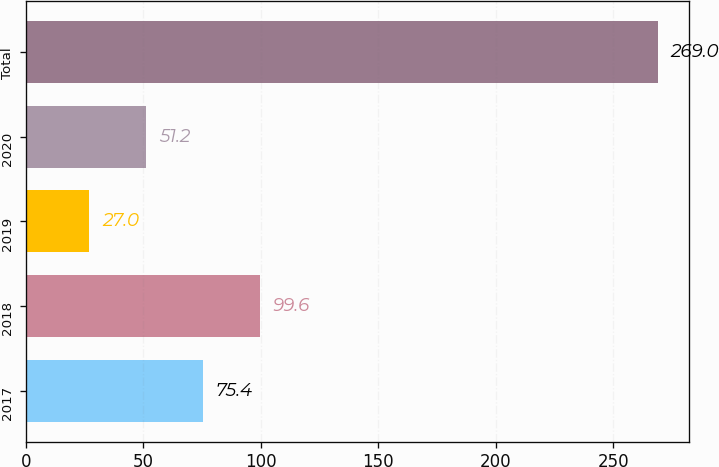Convert chart to OTSL. <chart><loc_0><loc_0><loc_500><loc_500><bar_chart><fcel>2017<fcel>2018<fcel>2019<fcel>2020<fcel>Total<nl><fcel>75.4<fcel>99.6<fcel>27<fcel>51.2<fcel>269<nl></chart> 